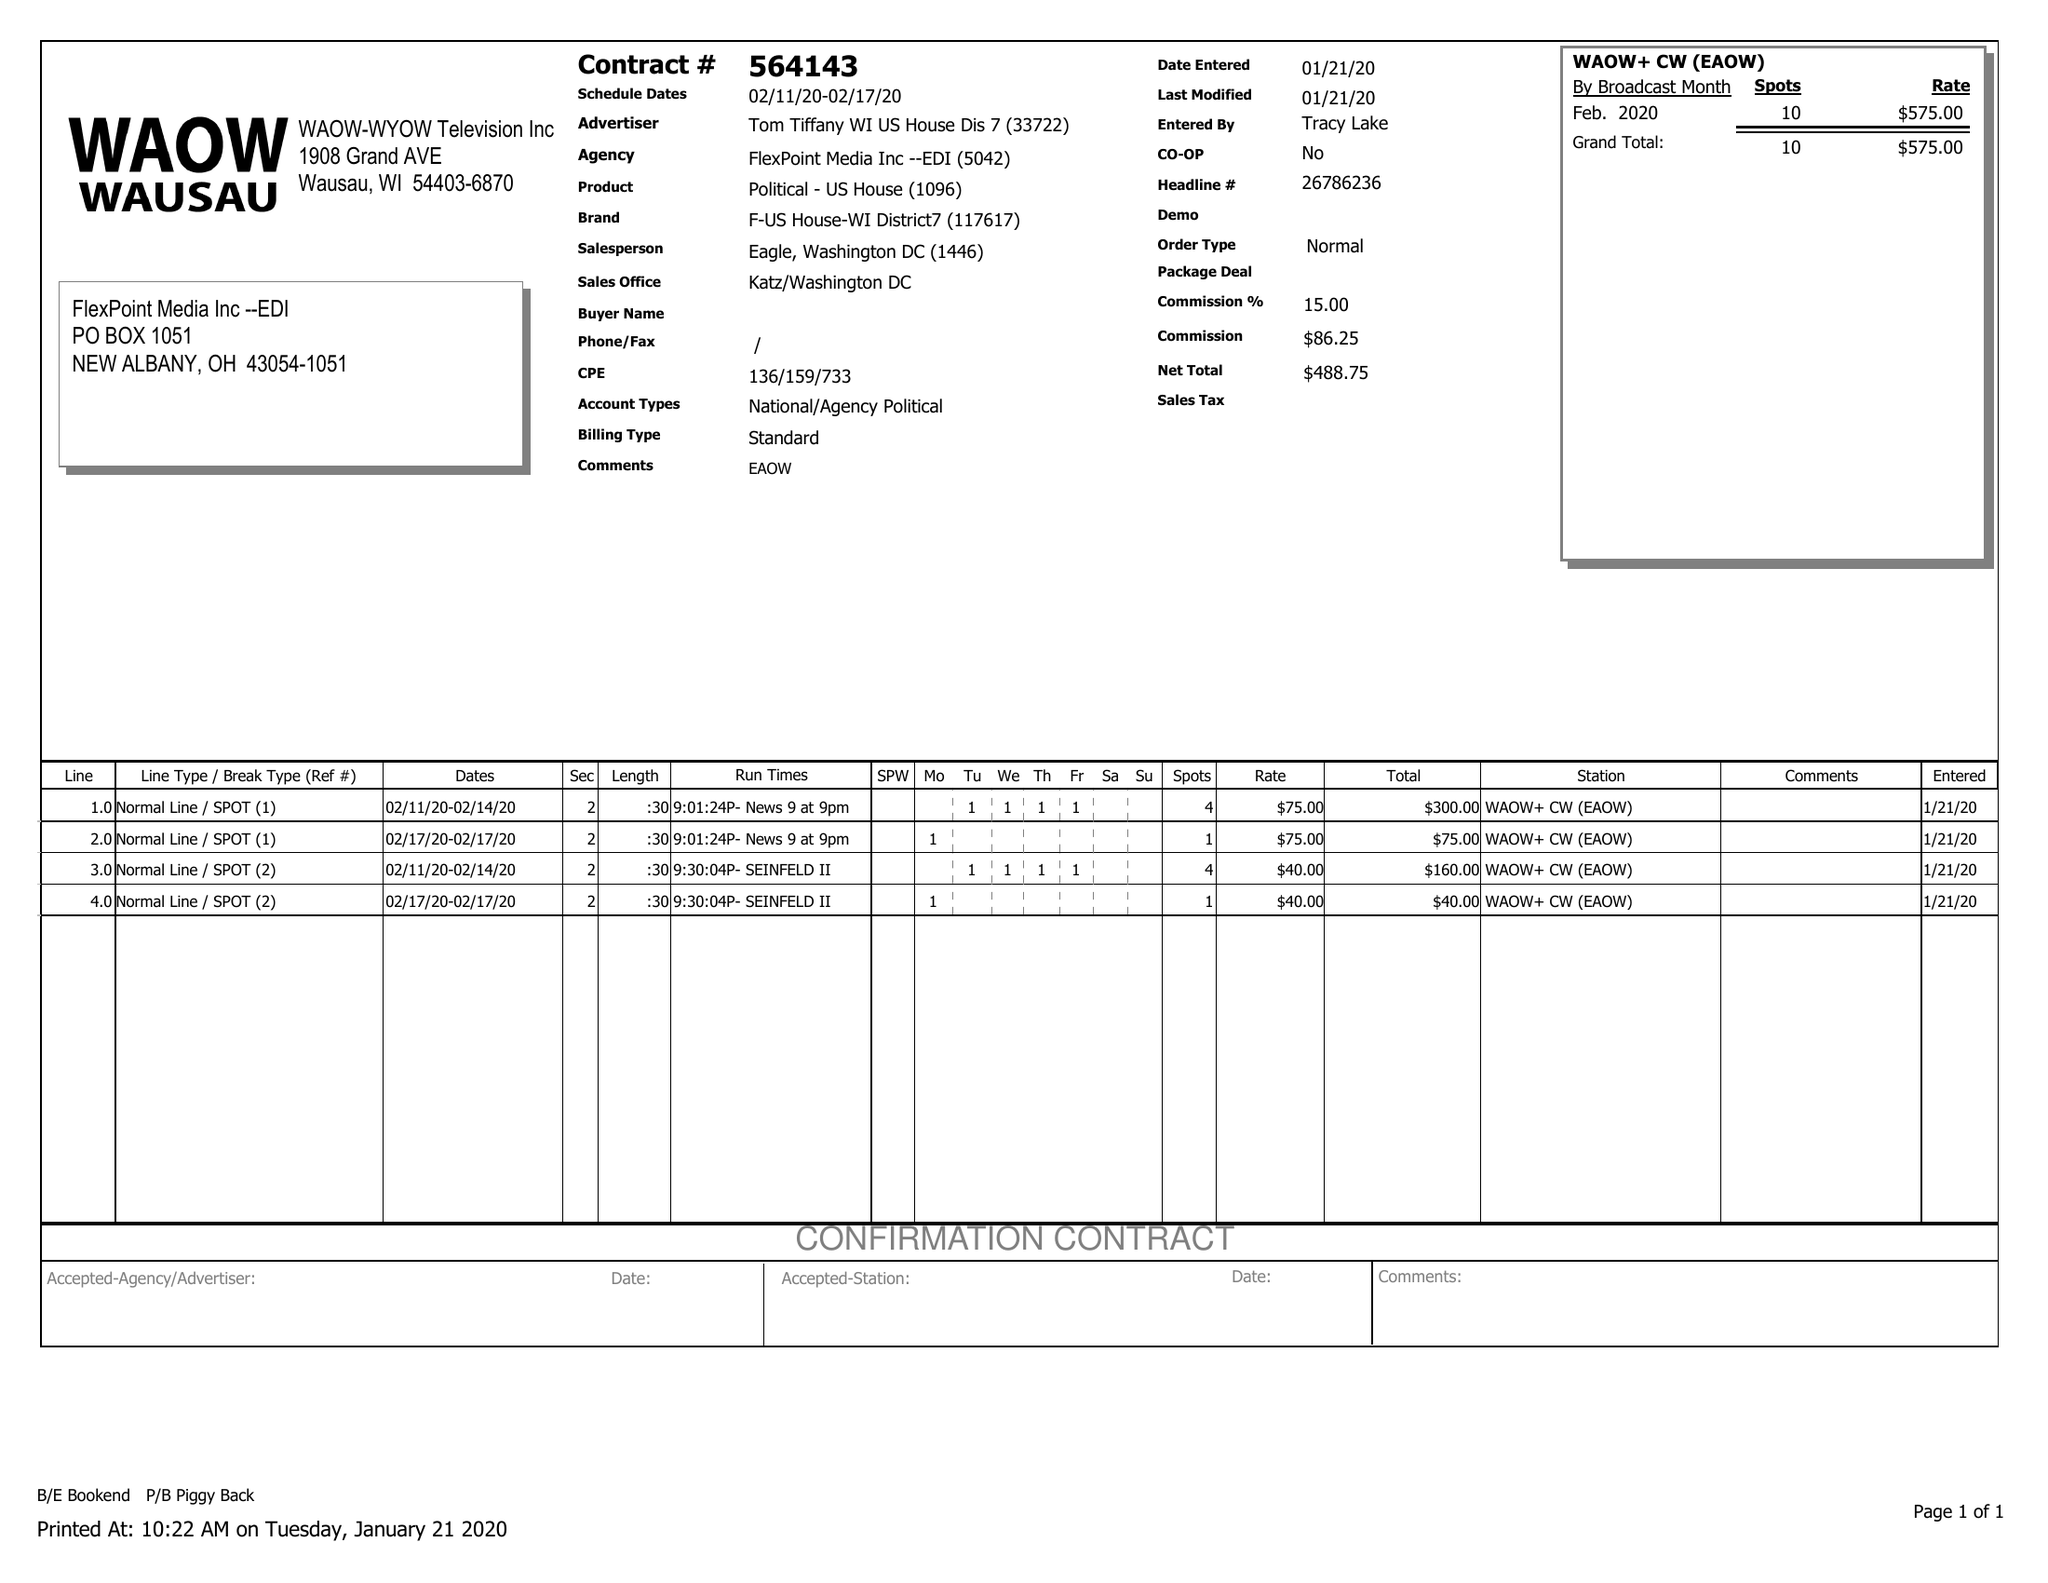What is the value for the contract_num?
Answer the question using a single word or phrase. 564143 